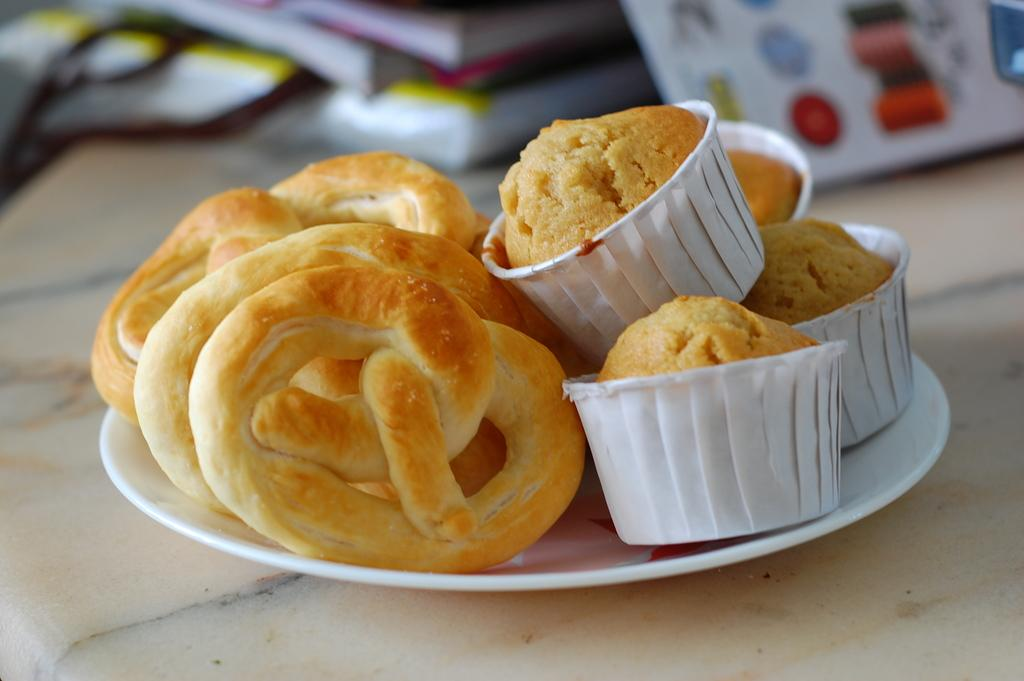What type of dessert can be seen in the image? There are cupcakes in the image. What else is on the plate with the cupcakes? There are other food items on a plate in the image. Where is the plate located? The plate is on a table. What else can be seen in the image besides food items? There are books present in the image. How does the cupcake stretch its legs in the image? Cupcakes do not have legs and cannot stretch them; they are a type of dessert. 